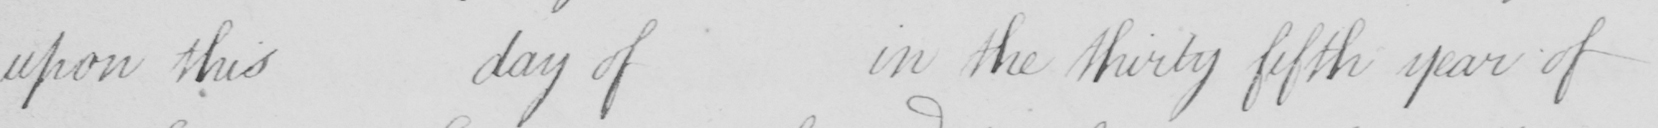Please transcribe the handwritten text in this image. upon this day of in the thirty fifth year of 